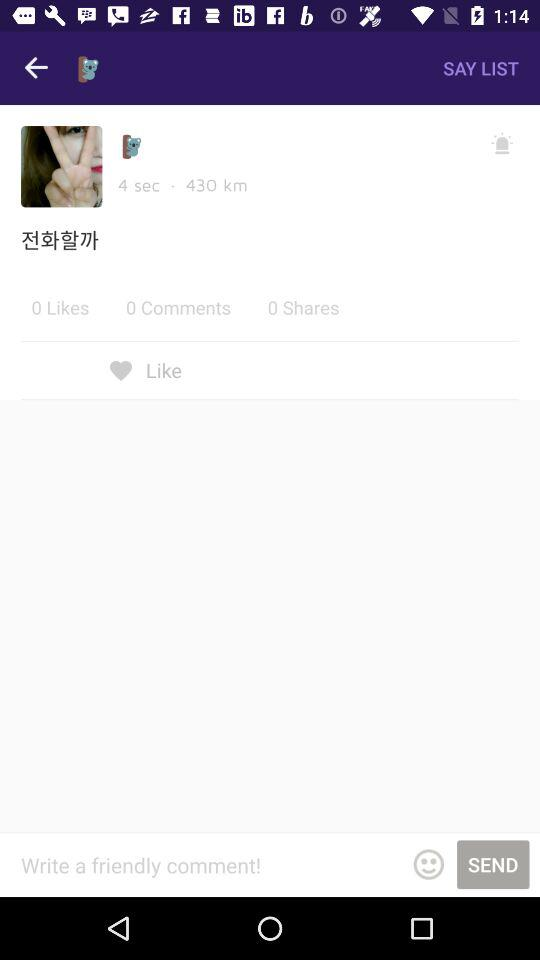What is the total number of comments? The total number of comments is 0. 